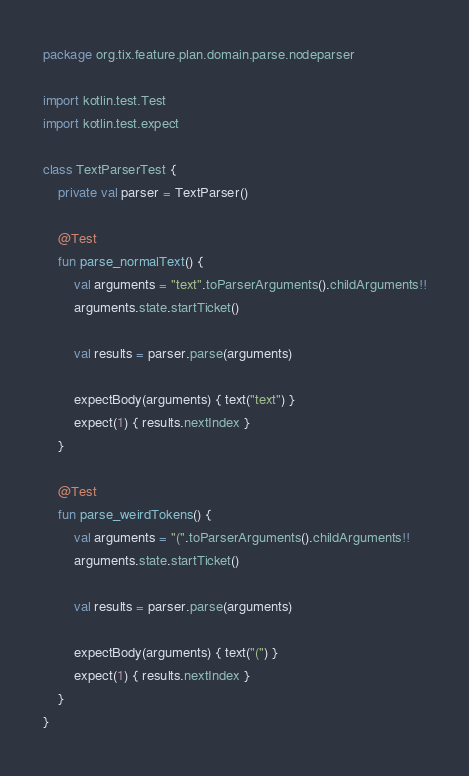Convert code to text. <code><loc_0><loc_0><loc_500><loc_500><_Kotlin_>package org.tix.feature.plan.domain.parse.nodeparser

import kotlin.test.Test
import kotlin.test.expect

class TextParserTest {
    private val parser = TextParser()

    @Test
    fun parse_normalText() {
        val arguments = "text".toParserArguments().childArguments!!
        arguments.state.startTicket()

        val results = parser.parse(arguments)

        expectBody(arguments) { text("text") }
        expect(1) { results.nextIndex }
    }

    @Test
    fun parse_weirdTokens() {
        val arguments = "(".toParserArguments().childArguments!!
        arguments.state.startTicket()

        val results = parser.parse(arguments)

        expectBody(arguments) { text("(") }
        expect(1) { results.nextIndex }
    }
}</code> 